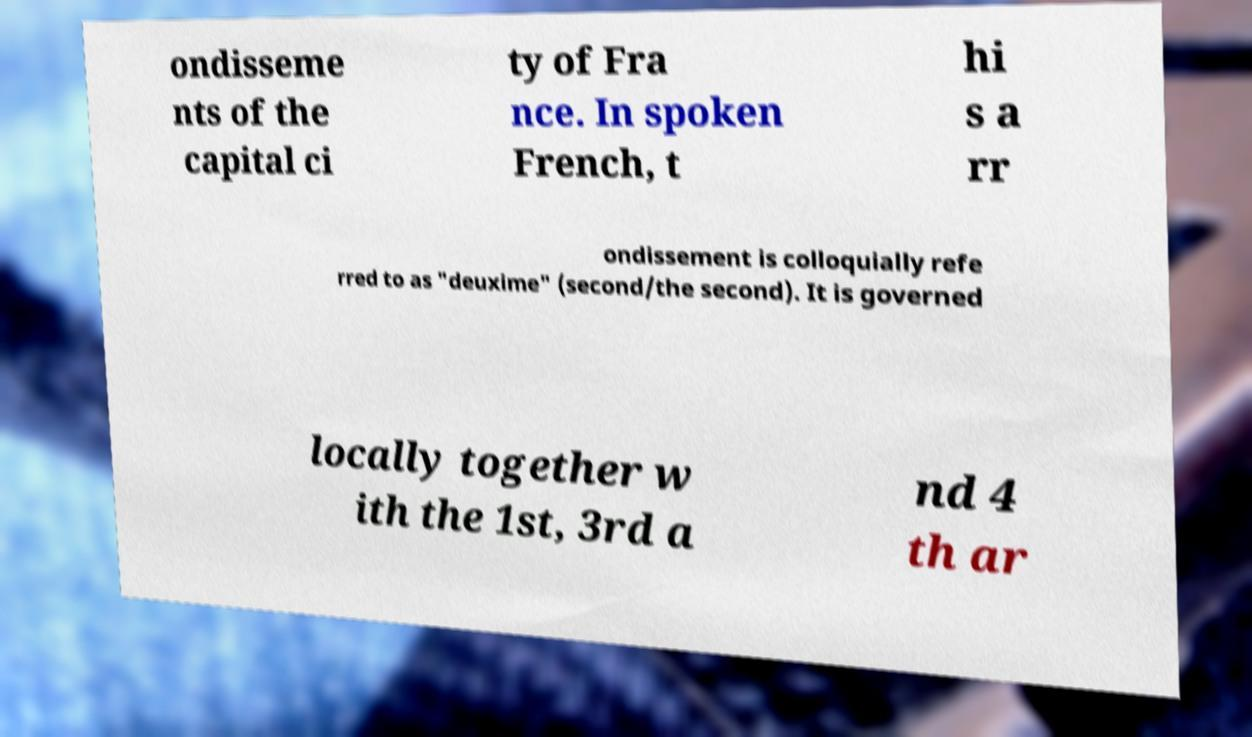There's text embedded in this image that I need extracted. Can you transcribe it verbatim? ondisseme nts of the capital ci ty of Fra nce. In spoken French, t hi s a rr ondissement is colloquially refe rred to as "deuxime" (second/the second). It is governed locally together w ith the 1st, 3rd a nd 4 th ar 